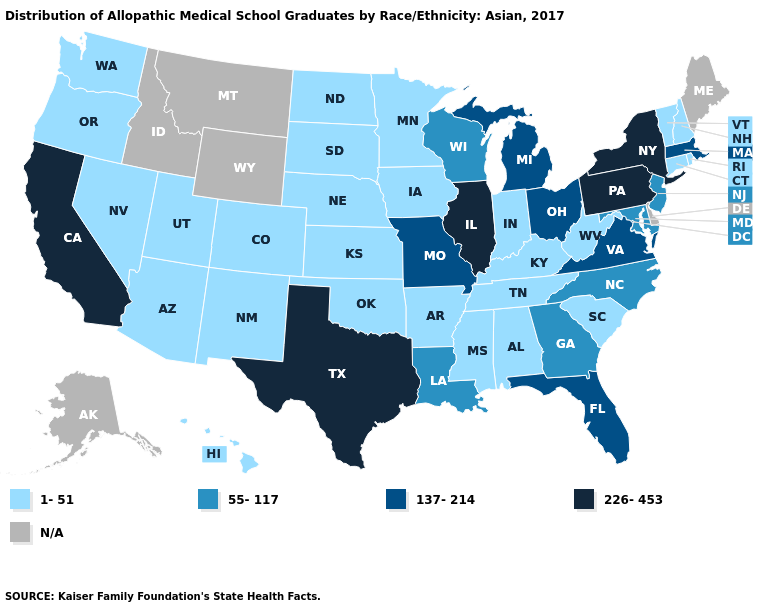Does California have the lowest value in the West?
Give a very brief answer. No. Does California have the lowest value in the West?
Be succinct. No. What is the highest value in the West ?
Give a very brief answer. 226-453. What is the value of Alabama?
Concise answer only. 1-51. What is the value of Rhode Island?
Keep it brief. 1-51. Which states have the lowest value in the USA?
Be succinct. Alabama, Arizona, Arkansas, Colorado, Connecticut, Hawaii, Indiana, Iowa, Kansas, Kentucky, Minnesota, Mississippi, Nebraska, Nevada, New Hampshire, New Mexico, North Dakota, Oklahoma, Oregon, Rhode Island, South Carolina, South Dakota, Tennessee, Utah, Vermont, Washington, West Virginia. What is the value of Colorado?
Be succinct. 1-51. What is the value of New Mexico?
Write a very short answer. 1-51. Does the first symbol in the legend represent the smallest category?
Quick response, please. Yes. What is the highest value in states that border Pennsylvania?
Be succinct. 226-453. What is the highest value in the USA?
Keep it brief. 226-453. Among the states that border Wisconsin , which have the lowest value?
Short answer required. Iowa, Minnesota. What is the value of Arizona?
Give a very brief answer. 1-51. Among the states that border Oklahoma , which have the highest value?
Short answer required. Texas. What is the value of South Dakota?
Quick response, please. 1-51. 